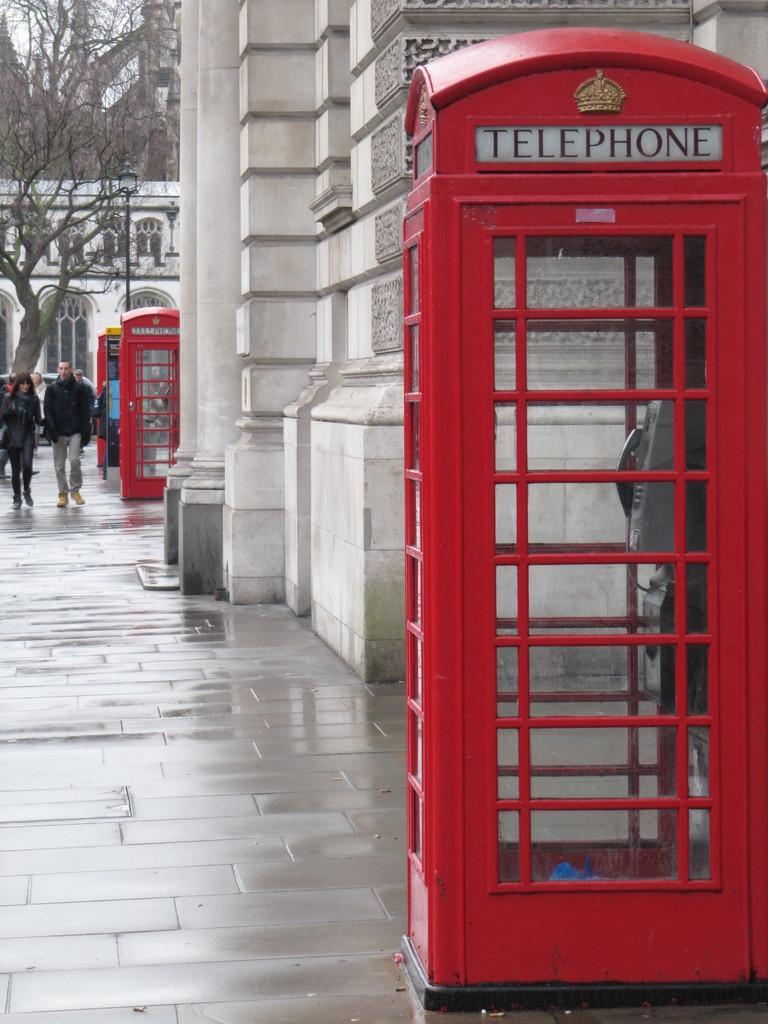Can you describe this image briefly? In this image, I can see the buildings with the pillars and windows. These are the telephone booths. I can see two people walking on the pathway. This looks like a tree. I can see a telephone inside a telephone booth. 